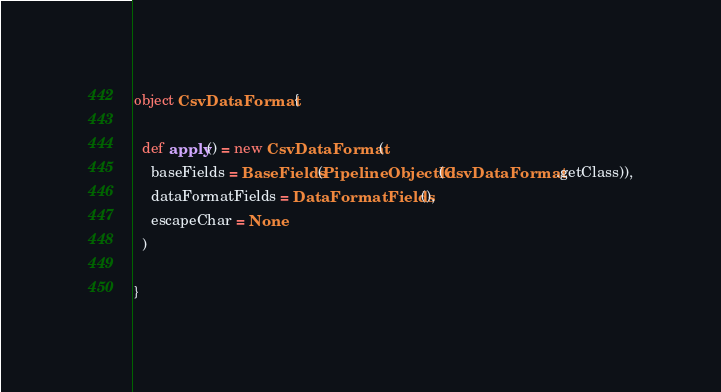<code> <loc_0><loc_0><loc_500><loc_500><_Scala_>
object CsvDataFormat {

  def apply() = new CsvDataFormat(
    baseFields = BaseFields(PipelineObjectId(CsvDataFormat.getClass)),
    dataFormatFields = DataFormatFields(),
    escapeChar = None
  )

}
</code> 